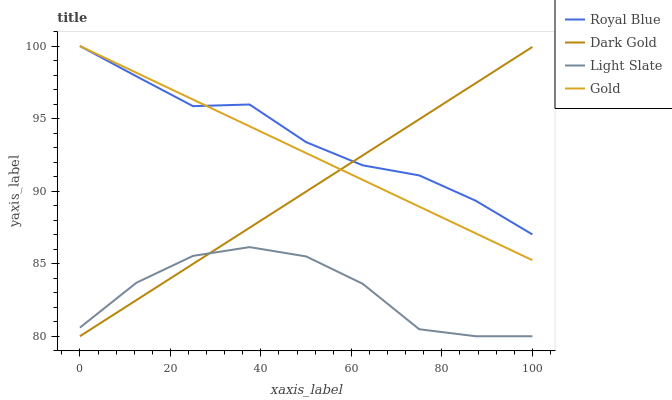Does Light Slate have the minimum area under the curve?
Answer yes or no. Yes. Does Royal Blue have the maximum area under the curve?
Answer yes or no. Yes. Does Gold have the minimum area under the curve?
Answer yes or no. No. Does Gold have the maximum area under the curve?
Answer yes or no. No. Is Gold the smoothest?
Answer yes or no. Yes. Is Light Slate the roughest?
Answer yes or no. Yes. Is Royal Blue the smoothest?
Answer yes or no. No. Is Royal Blue the roughest?
Answer yes or no. No. Does Light Slate have the lowest value?
Answer yes or no. Yes. Does Gold have the lowest value?
Answer yes or no. No. Does Gold have the highest value?
Answer yes or no. Yes. Does Dark Gold have the highest value?
Answer yes or no. No. Is Light Slate less than Royal Blue?
Answer yes or no. Yes. Is Gold greater than Light Slate?
Answer yes or no. Yes. Does Dark Gold intersect Royal Blue?
Answer yes or no. Yes. Is Dark Gold less than Royal Blue?
Answer yes or no. No. Is Dark Gold greater than Royal Blue?
Answer yes or no. No. Does Light Slate intersect Royal Blue?
Answer yes or no. No. 